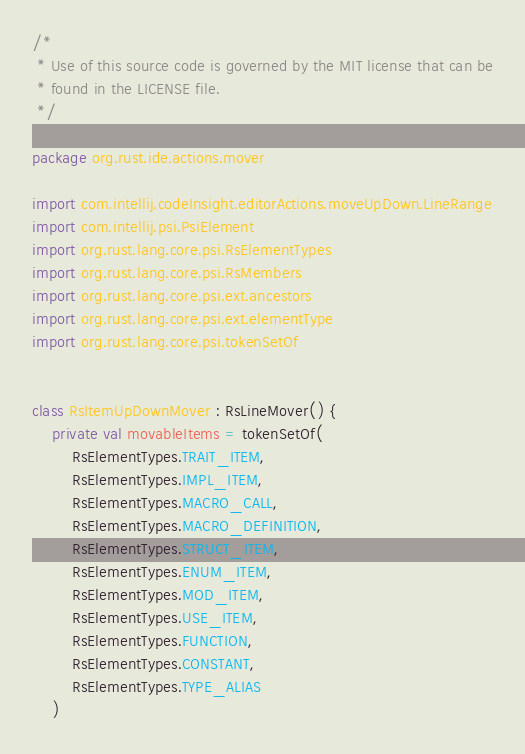<code> <loc_0><loc_0><loc_500><loc_500><_Kotlin_>/*
 * Use of this source code is governed by the MIT license that can be
 * found in the LICENSE file.
 */

package org.rust.ide.actions.mover

import com.intellij.codeInsight.editorActions.moveUpDown.LineRange
import com.intellij.psi.PsiElement
import org.rust.lang.core.psi.RsElementTypes
import org.rust.lang.core.psi.RsMembers
import org.rust.lang.core.psi.ext.ancestors
import org.rust.lang.core.psi.ext.elementType
import org.rust.lang.core.psi.tokenSetOf


class RsItemUpDownMover : RsLineMover() {
    private val movableItems = tokenSetOf(
        RsElementTypes.TRAIT_ITEM,
        RsElementTypes.IMPL_ITEM,
        RsElementTypes.MACRO_CALL,
        RsElementTypes.MACRO_DEFINITION,
        RsElementTypes.STRUCT_ITEM,
        RsElementTypes.ENUM_ITEM,
        RsElementTypes.MOD_ITEM,
        RsElementTypes.USE_ITEM,
        RsElementTypes.FUNCTION,
        RsElementTypes.CONSTANT,
        RsElementTypes.TYPE_ALIAS
    )
</code> 